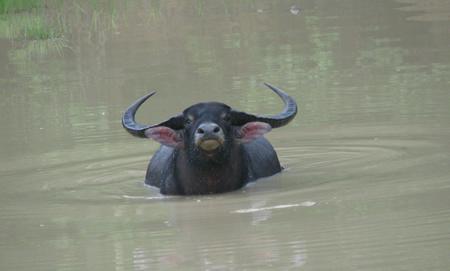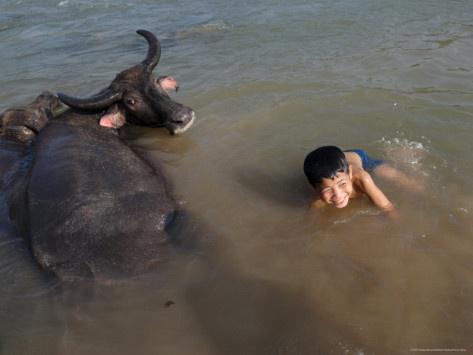The first image is the image on the left, the second image is the image on the right. Assess this claim about the two images: "There are two water buffallos wading in water.". Correct or not? Answer yes or no. Yes. The first image is the image on the left, the second image is the image on the right. For the images shown, is this caption "There is more than one animal species." true? Answer yes or no. Yes. 